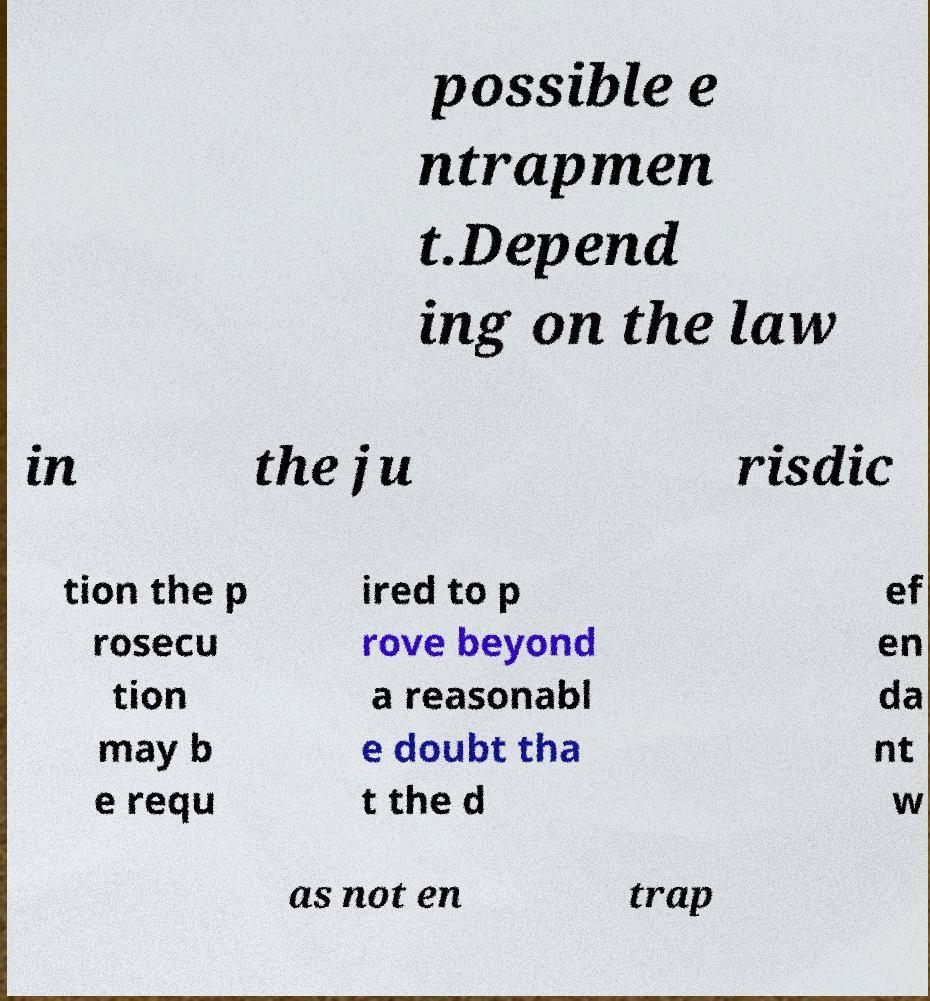For documentation purposes, I need the text within this image transcribed. Could you provide that? possible e ntrapmen t.Depend ing on the law in the ju risdic tion the p rosecu tion may b e requ ired to p rove beyond a reasonabl e doubt tha t the d ef en da nt w as not en trap 